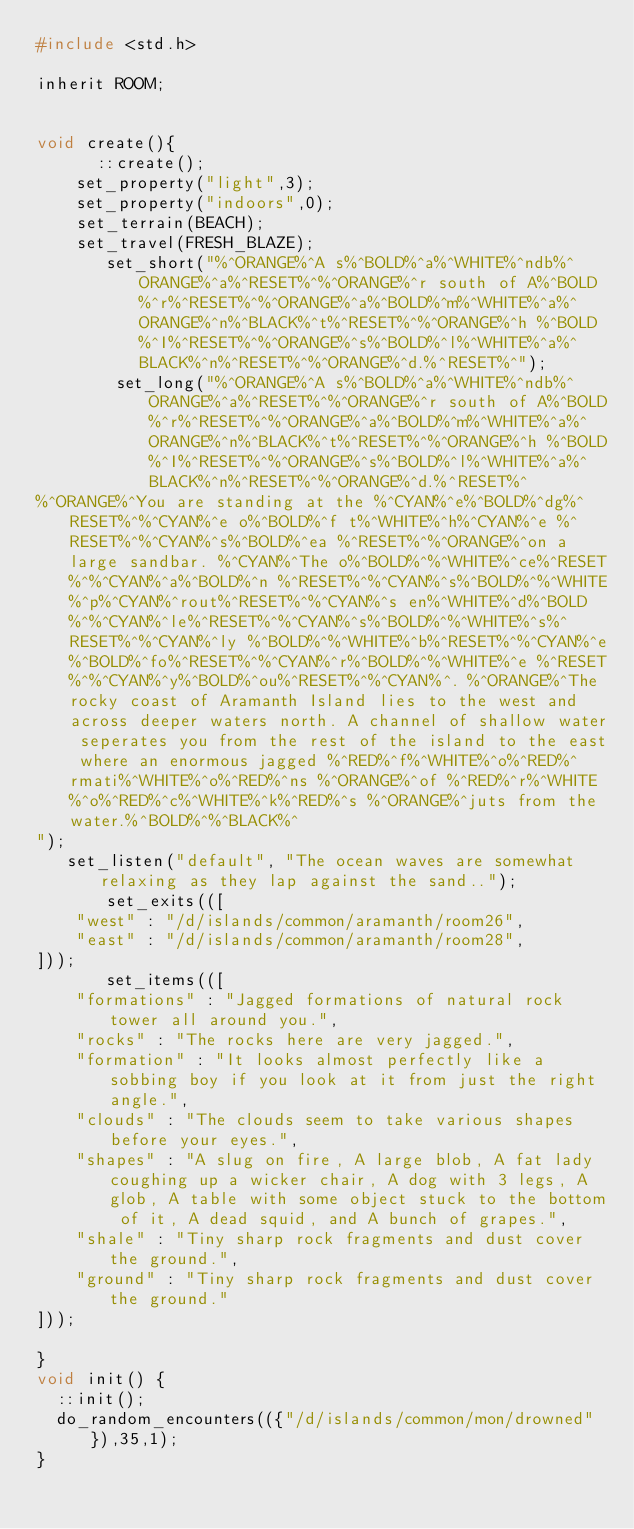<code> <loc_0><loc_0><loc_500><loc_500><_C_>#include <std.h>

inherit ROOM;


void create(){
      ::create();
	set_property("light",3);
	set_property("indoors",0);
	set_terrain(BEACH);
	set_travel(FRESH_BLAZE);
       set_short("%^ORANGE%^A s%^BOLD%^a%^WHITE%^ndb%^ORANGE%^a%^RESET%^%^ORANGE%^r south of A%^BOLD%^r%^RESET%^%^ORANGE%^a%^BOLD%^m%^WHITE%^a%^ORANGE%^n%^BLACK%^t%^RESET%^%^ORANGE%^h %^BOLD%^I%^RESET%^%^ORANGE%^s%^BOLD%^l%^WHITE%^a%^BLACK%^n%^RESET%^%^ORANGE%^d.%^RESET%^");
        set_long("%^ORANGE%^A s%^BOLD%^a%^WHITE%^ndb%^ORANGE%^a%^RESET%^%^ORANGE%^r south of A%^BOLD%^r%^RESET%^%^ORANGE%^a%^BOLD%^m%^WHITE%^a%^ORANGE%^n%^BLACK%^t%^RESET%^%^ORANGE%^h %^BOLD%^I%^RESET%^%^ORANGE%^s%^BOLD%^l%^WHITE%^a%^BLACK%^n%^RESET%^%^ORANGE%^d.%^RESET%^
%^ORANGE%^You are standing at the %^CYAN%^e%^BOLD%^dg%^RESET%^%^CYAN%^e o%^BOLD%^f t%^WHITE%^h%^CYAN%^e %^RESET%^%^CYAN%^s%^BOLD%^ea %^RESET%^%^ORANGE%^on a large sandbar. %^CYAN%^The o%^BOLD%^%^WHITE%^ce%^RESET%^%^CYAN%^a%^BOLD%^n %^RESET%^%^CYAN%^s%^BOLD%^%^WHITE%^p%^CYAN%^rout%^RESET%^%^CYAN%^s en%^WHITE%^d%^BOLD%^%^CYAN%^le%^RESET%^%^CYAN%^s%^BOLD%^%^WHITE%^s%^RESET%^%^CYAN%^ly %^BOLD%^%^WHITE%^b%^RESET%^%^CYAN%^e%^BOLD%^fo%^RESET%^%^CYAN%^r%^BOLD%^%^WHITE%^e %^RESET%^%^CYAN%^y%^BOLD%^ou%^RESET%^%^CYAN%^. %^ORANGE%^The rocky coast of Aramanth Island lies to the west and across deeper waters north. A channel of shallow water seperates you from the rest of the island to the east where an enormous jagged %^RED%^f%^WHITE%^o%^RED%^rmati%^WHITE%^o%^RED%^ns %^ORANGE%^of %^RED%^r%^WHITE%^o%^RED%^c%^WHITE%^k%^RED%^s %^ORANGE%^juts from the water.%^BOLD%^%^BLACK%^
");
   set_listen("default", "The ocean waves are somewhat relaxing as they lap against the sand..");
       set_exits(([
    "west" : "/d/islands/common/aramanth/room26",
    "east" : "/d/islands/common/aramanth/room28",
]));
       set_items(([
    "formations" : "Jagged formations of natural rock tower all around you.",
    "rocks" : "The rocks here are very jagged.",
    "formation" : "It looks almost perfectly like a sobbing boy if you look at it from just the right angle.",
    "clouds" : "The clouds seem to take various shapes before your eyes.",
    "shapes" : "A slug on fire, A large blob, A fat lady coughing up a wicker chair, A dog with 3 legs, A glob, A table with some object stuck to the bottom of it, A dead squid, and A bunch of grapes.",
    "shale" : "Tiny sharp rock fragments and dust cover the ground.",
    "ground" : "Tiny sharp rock fragments and dust cover the ground."
]));
	
}
void init() {
  ::init();
  do_random_encounters(({"/d/islands/common/mon/drowned"}),35,1);
}
</code> 